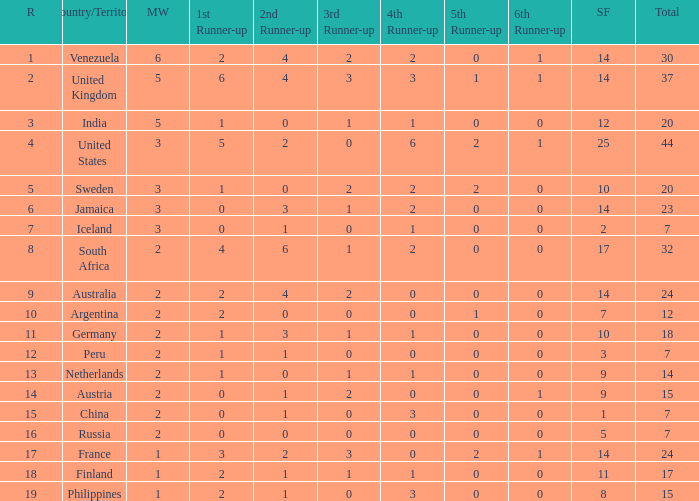Parse the table in full. {'header': ['R', 'Country/Territory', 'MW', '1st Runner-up', '2nd Runner-up', '3rd Runner-up', '4th Runner-up', '5th Runner-up', '6th Runner-up', 'SF', 'Total'], 'rows': [['1', 'Venezuela', '6', '2', '4', '2', '2', '0', '1', '14', '30'], ['2', 'United Kingdom', '5', '6', '4', '3', '3', '1', '1', '14', '37'], ['3', 'India', '5', '1', '0', '1', '1', '0', '0', '12', '20'], ['4', 'United States', '3', '5', '2', '0', '6', '2', '1', '25', '44'], ['5', 'Sweden', '3', '1', '0', '2', '2', '2', '0', '10', '20'], ['6', 'Jamaica', '3', '0', '3', '1', '2', '0', '0', '14', '23'], ['7', 'Iceland', '3', '0', '1', '0', '1', '0', '0', '2', '7'], ['8', 'South Africa', '2', '4', '6', '1', '2', '0', '0', '17', '32'], ['9', 'Australia', '2', '2', '4', '2', '0', '0', '0', '14', '24'], ['10', 'Argentina', '2', '2', '0', '0', '0', '1', '0', '7', '12'], ['11', 'Germany', '2', '1', '3', '1', '1', '0', '0', '10', '18'], ['12', 'Peru', '2', '1', '1', '0', '0', '0', '0', '3', '7'], ['13', 'Netherlands', '2', '1', '0', '1', '1', '0', '0', '9', '14'], ['14', 'Austria', '2', '0', '1', '2', '0', '0', '1', '9', '15'], ['15', 'China', '2', '0', '1', '0', '3', '0', '0', '1', '7'], ['16', 'Russia', '2', '0', '0', '0', '0', '0', '0', '5', '7'], ['17', 'France', '1', '3', '2', '3', '0', '2', '1', '14', '24'], ['18', 'Finland', '1', '2', '1', '1', '1', '0', '0', '11', '17'], ['19', 'Philippines', '1', '2', '1', '0', '3', '0', '0', '8', '15']]} What is venezuela's overall ranking? 30.0. 